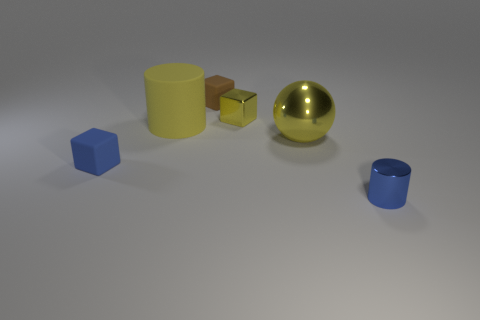Does the big metallic object have the same color as the big rubber cylinder?
Your answer should be compact. Yes. Are there any blocks in front of the tiny metal thing that is behind the blue object on the right side of the large shiny object?
Your response must be concise. Yes. The thing that is both in front of the large ball and behind the blue metal cylinder has what shape?
Ensure brevity in your answer.  Cube. Are there any tiny rubber things that have the same color as the large metallic thing?
Your answer should be very brief. No. What is the color of the tiny matte object in front of the yellow object behind the big cylinder?
Offer a terse response. Blue. How big is the cylinder that is to the left of the small metallic object that is to the left of the tiny metal thing that is in front of the rubber cylinder?
Provide a succinct answer. Large. Does the tiny yellow object have the same material as the large thing that is left of the tiny brown cube?
Keep it short and to the point. No. What is the size of the yellow cylinder that is made of the same material as the tiny brown block?
Make the answer very short. Large. Is there another thing of the same shape as the small yellow object?
Your answer should be very brief. Yes. What number of things are either cylinders in front of the rubber cylinder or small brown matte things?
Your response must be concise. 2. 